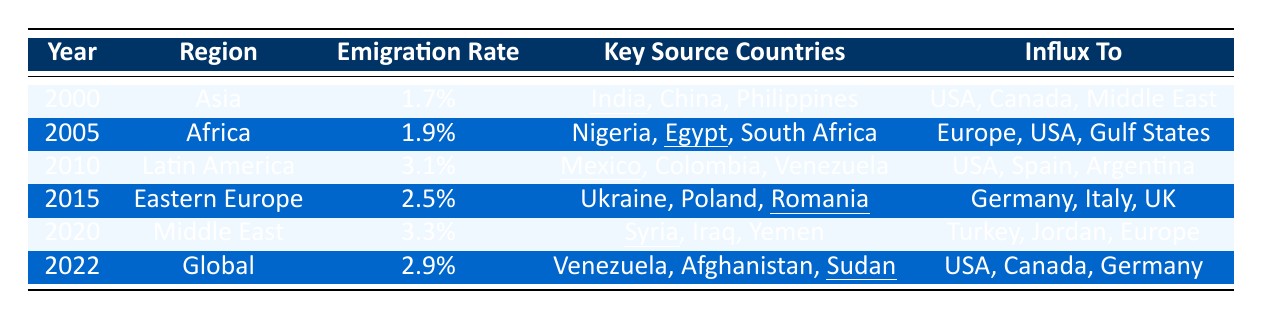What was the emigration rate from Asia in the year 2000? The table indicates that the emigration rate from Asia in 2000 is listed directly next to the region under the corresponding year. According to the data, it is 1.7%.
Answer: 1.7% Which region had the highest emigration rate in 2010? By examining the table, the emigration rate for Latin America in 2010 is 3.1%, and it is higher than any other region listed for that year.
Answer: Latin America What were the key source countries for migration from the Middle East in 2020? The table specifies the key source countries for each region in each year. In 2020, the key source countries listed for the Middle East are Syria, Iraq, and Yemen.
Answer: Syria, Iraq, Yemen Did the emigration rate increase from 2015 to 2022? To determine this, we compare the emigration rates for 2015 and 2022. The rate in 2015 was 2.5%, and in 2022 it was 2.9%. Since 2.9% is greater than 2.5%, the emigration rate did indeed increase.
Answer: Yes What is the sum of emigration rates from Africa in 2005 and Latin America in 2010? The emigration rate for Africa in 2005 is 1.9%, and for Latin America in 2010, it is 3.1%. Adding these two rates gives 1.9% + 3.1% = 5.0%.
Answer: 5.0% Which region had the lowest emigration rate in the years listed in the table? By comparing all the emigration rates in the table, we can see that the lowest rate is 1.7% from Asia in the year 2000.
Answer: Asia in 2000 What was the trend of emigration rates from Asia to the Middle East from 2000 to 2020? The emigration rate for Asia in 2000 was 1.7%, while the rate for the Middle East in 2020 was higher at 3.3%. This indicates an overall increase in emigration rates over the years.
Answer: Increase Which key source country appears both in 2010 and 2022? Looking at the key source countries in both years, the country "Venezuela" appears in the key source list for both 2010 (Latin America) and 2022 (Global).
Answer: Venezuela How many regions had an emigration rate of 2.5% or higher in 2015? In 2015, the emigration rate for Eastern Europe is 2.5%, and there may be other regions listed. Checking the other years shows that only this region had 2.5% or higher in 2015.
Answer: 1 If we consider the influx destinations for Latin America in 2010, which country is most mentioned? The influx destinations for 2010 are USA, Spain, and Argentina. The USA is the only country mentioned among the influx destinations across various years and regions.
Answer: USA 